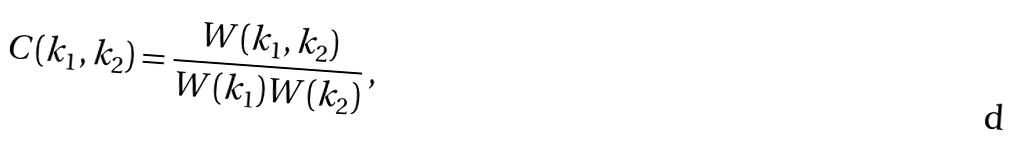<formula> <loc_0><loc_0><loc_500><loc_500>C ( { k _ { 1 } } , { k _ { 2 } } ) = \frac { W ( { k _ { 1 } } , { k _ { 2 } } ) } { W ( { k _ { 1 } } ) W ( { k _ { 2 } } ) } \, ,</formula> 